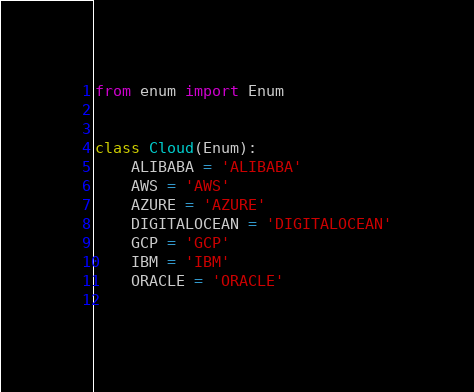<code> <loc_0><loc_0><loc_500><loc_500><_Python_>from enum import Enum


class Cloud(Enum):
    ALIBABA = 'ALIBABA'
    AWS = 'AWS'
    AZURE = 'AZURE'
    DIGITALOCEAN = 'DIGITALOCEAN'
    GCP = 'GCP'
    IBM = 'IBM'
    ORACLE = 'ORACLE'
    </code> 